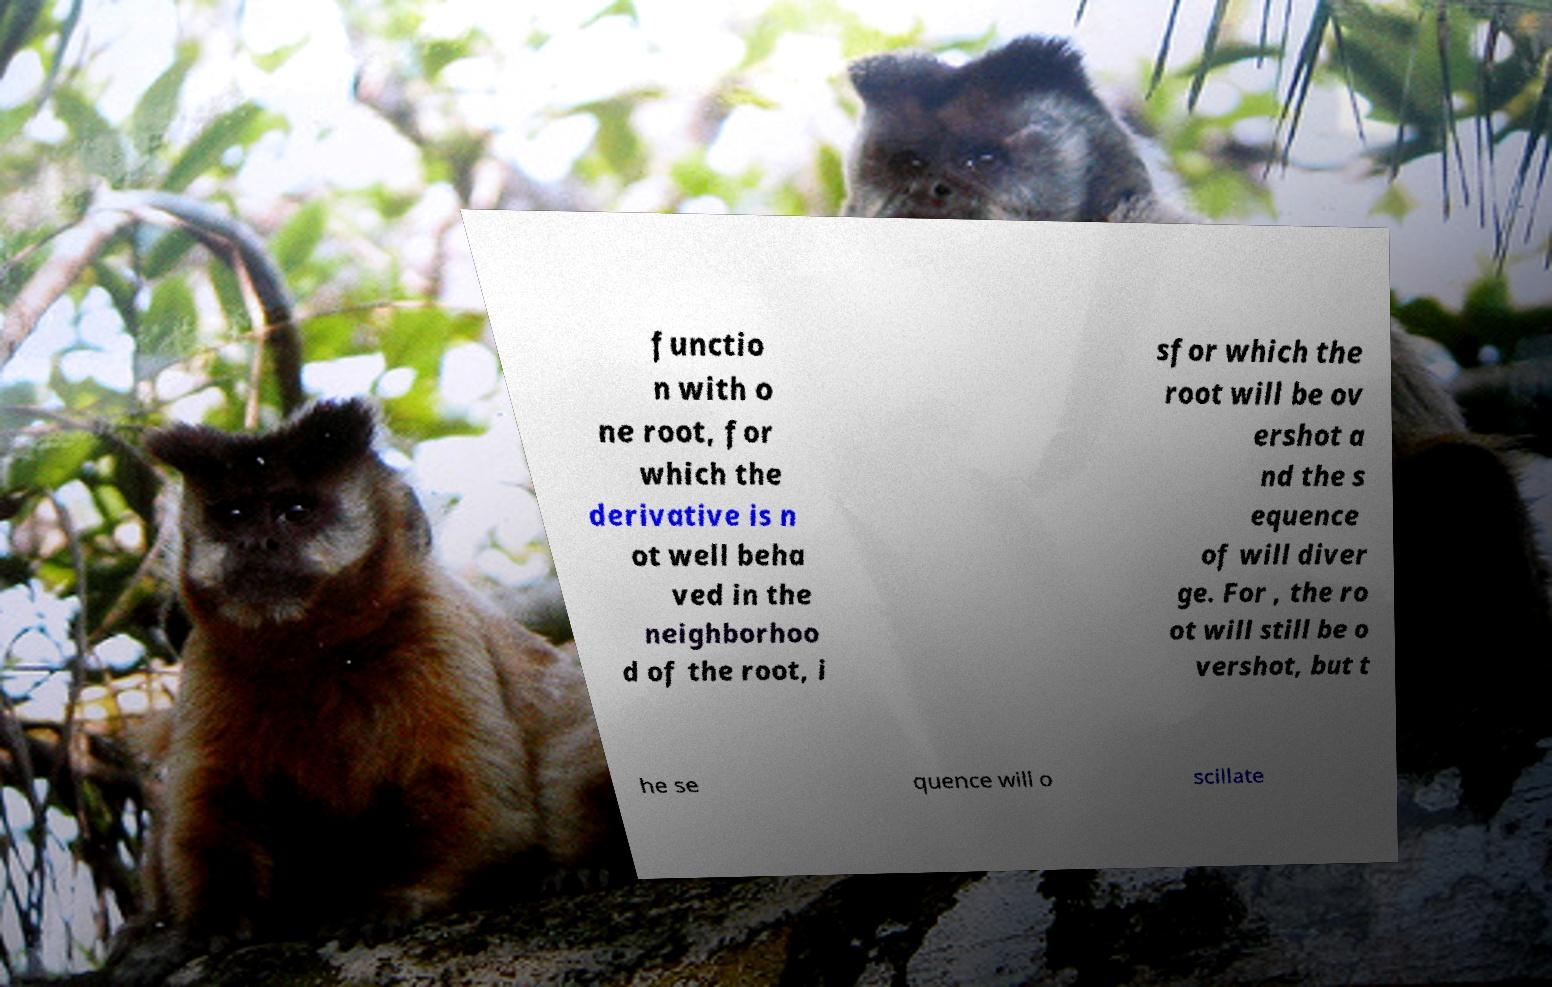Can you accurately transcribe the text from the provided image for me? functio n with o ne root, for which the derivative is n ot well beha ved in the neighborhoo d of the root, i sfor which the root will be ov ershot a nd the s equence of will diver ge. For , the ro ot will still be o vershot, but t he se quence will o scillate 